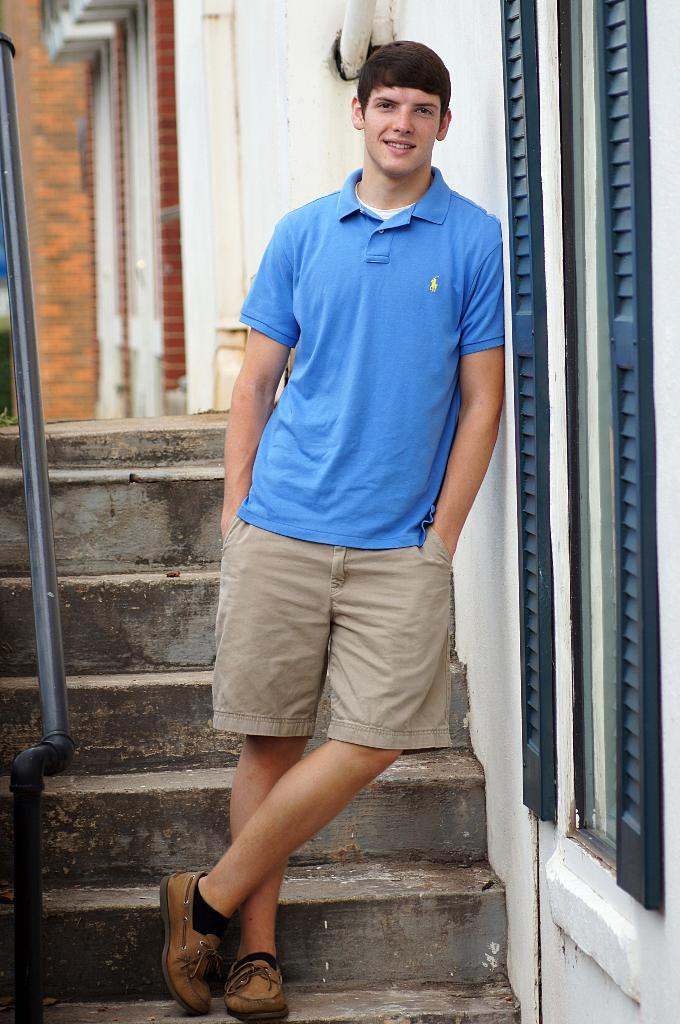What is the man in the image doing? The man is standing on the stairs. What can be seen on the wall in the image? There is a wall with windows in the image. What other object is present in the image? There is a pipe in the image. What type of game is being played on the stairs in the image? There is no game being played in the image; the man is simply standing on the stairs. How does the pipe affect the acoustics in the room in the image? The provided facts do not mention anything about the acoustics or the room, so we cannot determine how the pipe affects the acoustics. 